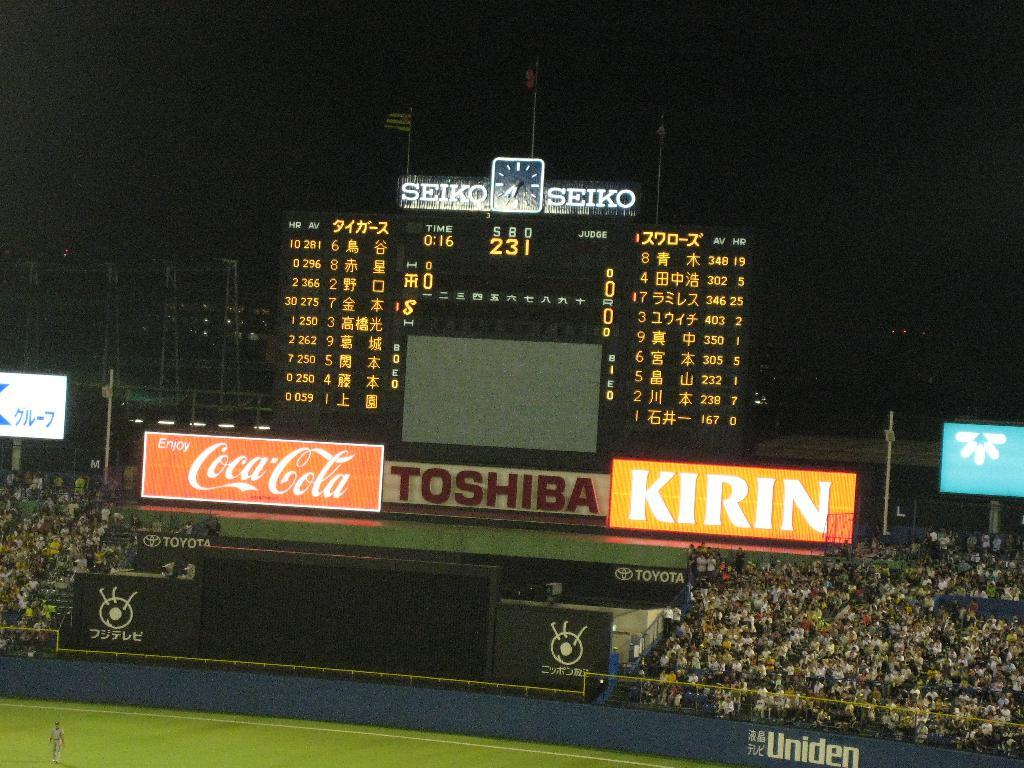<image>
Render a clear and concise summary of the photo. Coca-cola and Toshiba advertises on the soccer field sign. 